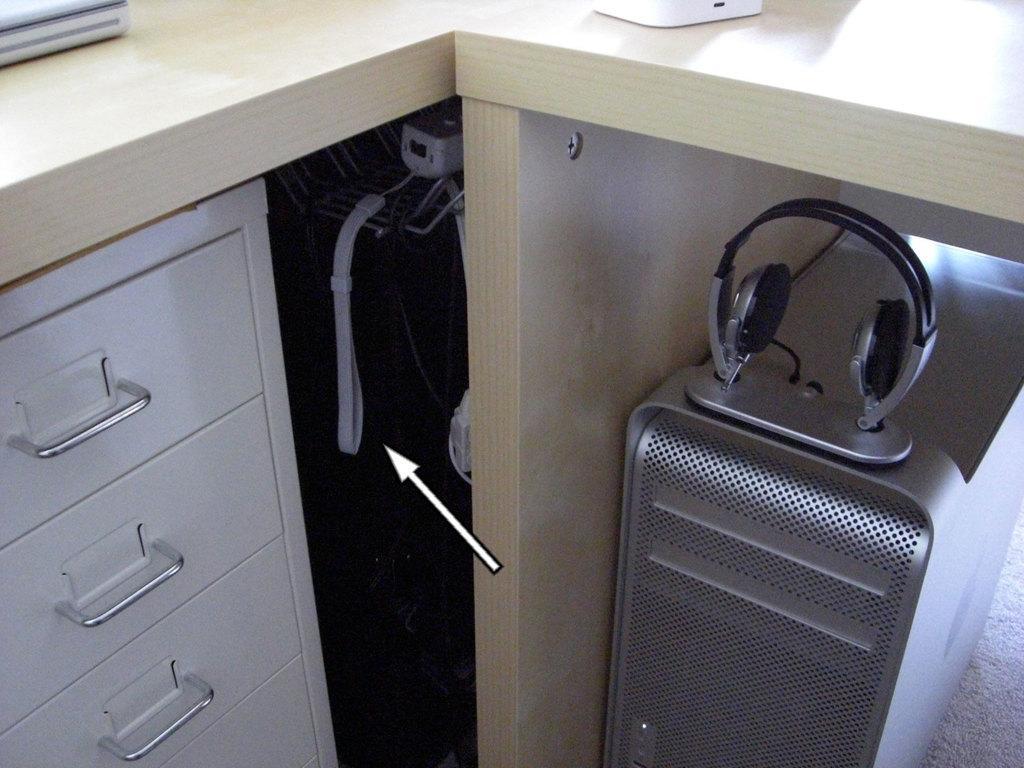Could you give a brief overview of what you see in this image? In this image I see the drawers over here and I see the headphone and I see that it is dark over here and I see the silver color thing over here and I see the table and I see white color things over here and I see an arrow over here. 